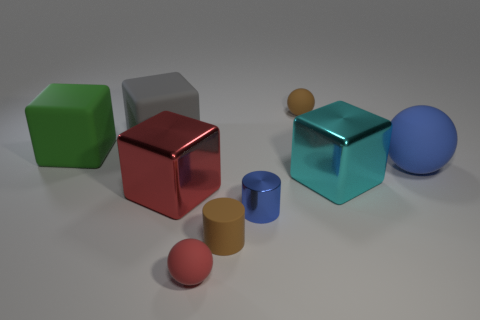The blue object that is the same material as the green thing is what size?
Your response must be concise. Large. What number of large green things are the same shape as the small blue shiny object?
Make the answer very short. 0. Do the metallic cube behind the big red metallic object and the metal cylinder have the same color?
Make the answer very short. No. What number of large gray matte objects are in front of the small ball that is behind the big shiny cube on the left side of the tiny brown rubber sphere?
Make the answer very short. 1. How many things are both to the left of the big gray matte object and to the right of the tiny blue shiny cylinder?
Make the answer very short. 0. What shape is the tiny shiny thing that is the same color as the big rubber ball?
Offer a terse response. Cylinder. Are the brown cylinder and the big green block made of the same material?
Ensure brevity in your answer.  Yes. There is a big matte thing right of the big cube that is right of the matte ball that is on the left side of the blue metal thing; what is its shape?
Provide a short and direct response. Sphere. Is the number of large green rubber objects that are in front of the cyan metal block less than the number of big green rubber things that are in front of the red metal object?
Provide a succinct answer. No. What shape is the red metallic object on the left side of the tiny sphere that is in front of the brown matte sphere?
Make the answer very short. Cube. 